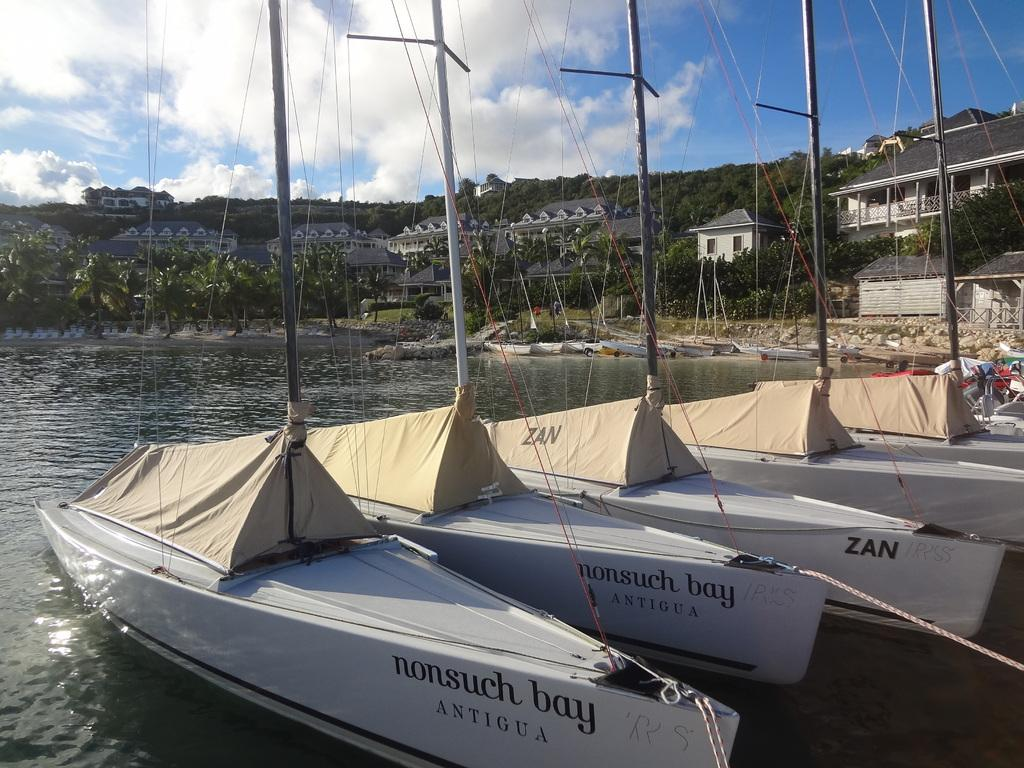What is happening in the water in the image? There are boats sailing in the water. What can be seen in the backdrop of the image? There are plants, trees, buildings, and a mountain in the backdrop. What is the condition of the sky in the image? The sky is clear in the image. What month is it in the image? The month cannot be determined from the image, as there is no information about the time of year. What attraction can be seen in the image? There is no specific attraction mentioned or visible in the image; it simply shows boats sailing in the water with a backdrop of natural and man-made elements. 